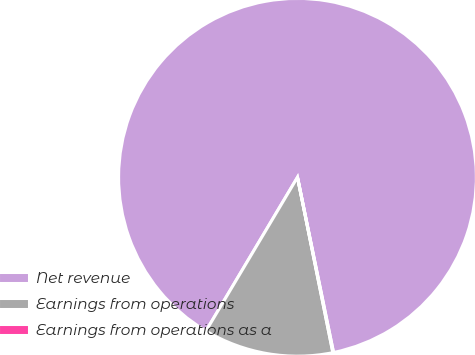Convert chart to OTSL. <chart><loc_0><loc_0><loc_500><loc_500><pie_chart><fcel>Net revenue<fcel>Earnings from operations<fcel>Earnings from operations as a<nl><fcel>88.22%<fcel>11.72%<fcel>0.06%<nl></chart> 